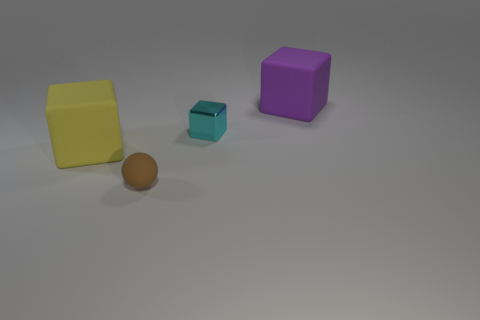Is there an object with a surface that reflects light differently than the others? Yes, the small turquoise block has a shiny surface which reflects light more prominently compared to the matte surfaces of the other objects. 